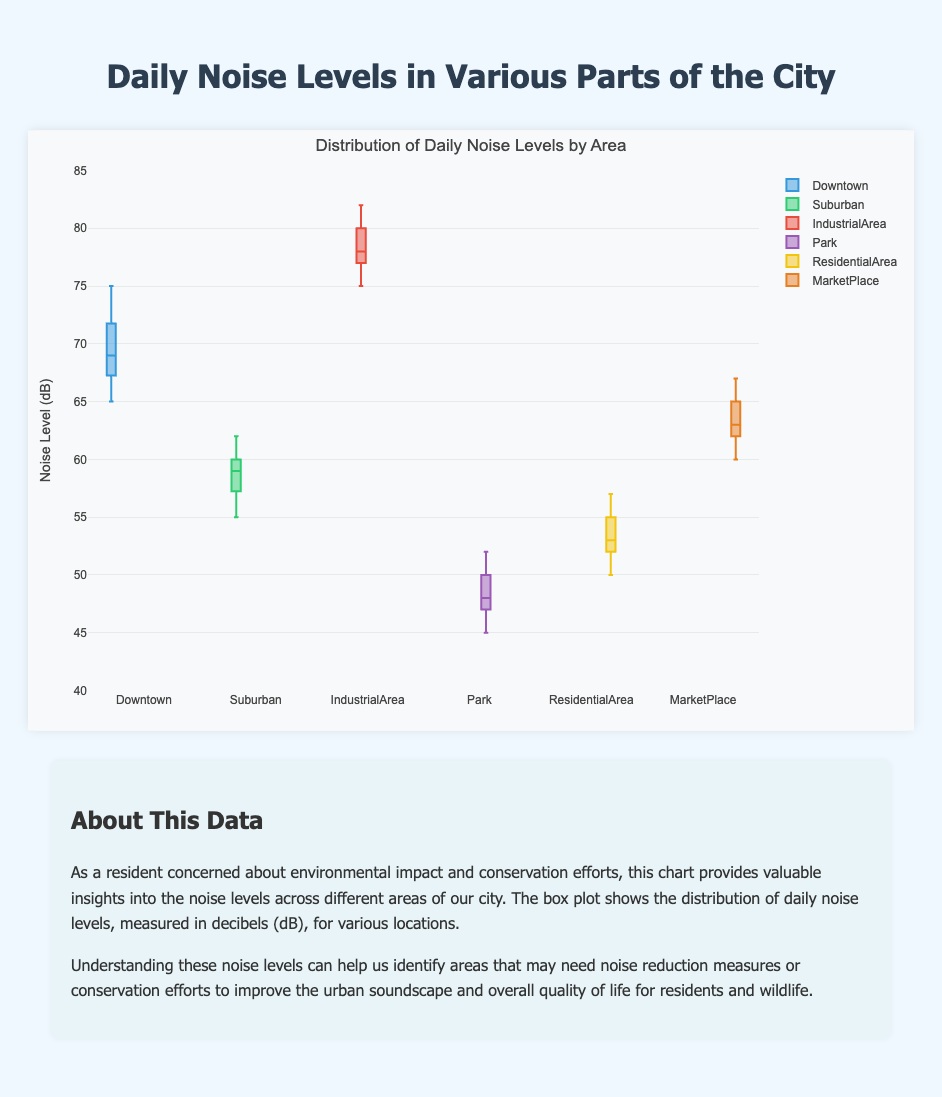What's the median noise level in the Downtown area? First, locate the box corresponding to the Downtown area on the plot. The median is indicated by the line inside the box.
Answer: 69 dB Which area has the widest range of noise levels? Identify the boxes, noting the range from the bottom whisker to the top whisker for each area. The IndustrialArea has the widest range from approximately 75 to 82 dB.
Answer: IndustrialArea What is the interquartile range (IQR) for the MarketPlace area? Find the lower quartile (Q1) and upper quartile (Q3) by noting the box bottom and top, respectively. Then, calculate the IQR (Q3 - Q1). Q3 is 65 and Q1 is 62.
Answer: 3 dB How do the noise levels in Park compare to those in Suburban areas? Compare the boxplots of Park and Suburban areas. Notice the medians, IQR, and overall spread. Park's median (48 dB) is much lower than Suburban's median (58 dB).
Answer: Park has lower noise levels Which area has the highest median noise level? Look at the boxplots and identify the highest median line across all regions. The IndustrialArea has the highest median.
Answer: IndustrialArea Are the noise levels in ResidentialArea higher than in the Park? Compare the medians and the spread of the boxplots. The ResidentialArea median (53 dB) is higher than the Park's median (48 dB).
Answer: Yes What is the minimum noise level recorded in the Suburban area? Locate the bottom whisker of the Suburban boxplot, representing the minimum value. It is at 55 dB.
Answer: 55 dB Which area has the most consistent (least variable) noise levels? Identify the boxplot with the smallest range from whisker to whisker. The Park area has the smallest range.
Answer: Park From highest to lowest, rank the areas based on their median noise levels. Determine the median values for each area: IndustrialArea (78 dB), Downtown (69 dB), MarketPlace (63 dB), Suburban (58 dB), ResidentialArea (53 dB), Park (48 dB).
Answer: IndustrialArea, Downtown, MarketPlace, Suburban, ResidentialArea, Park What is the upper quartile (Q3) value for the ResidentialArea? Locate the top of the box for ResidentialArea, representing the upper quartile.
Answer: 55 dB 